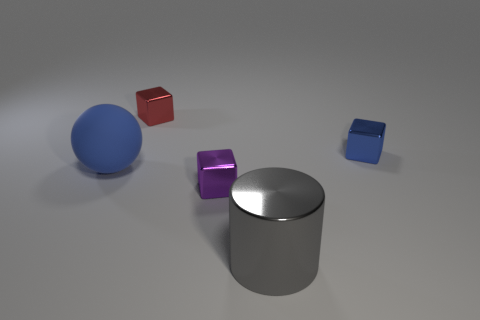Is the size of the red object behind the purple metal cube the same as the big cylinder?
Provide a succinct answer. No. Is the color of the small metal thing that is right of the big gray metal object the same as the matte object?
Your response must be concise. Yes. The thing behind the metal thing that is right of the big object that is in front of the large blue matte thing is what color?
Provide a succinct answer. Red. Is the number of gray objects behind the tiny blue thing greater than the number of large blue spheres to the right of the red metallic thing?
Your answer should be very brief. No. How many other objects are the same size as the gray metal cylinder?
Provide a short and direct response. 1. There is a cube that is the same color as the ball; what is its size?
Your answer should be very brief. Small. There is a blue object that is in front of the object that is right of the large gray thing; what is its material?
Your answer should be compact. Rubber. There is a large blue thing; are there any small metallic things behind it?
Your answer should be very brief. Yes. Are there more purple metal objects that are on the left side of the tiny blue thing than purple objects?
Offer a very short reply. No. Are there any metallic things that have the same color as the big matte thing?
Offer a very short reply. Yes. 